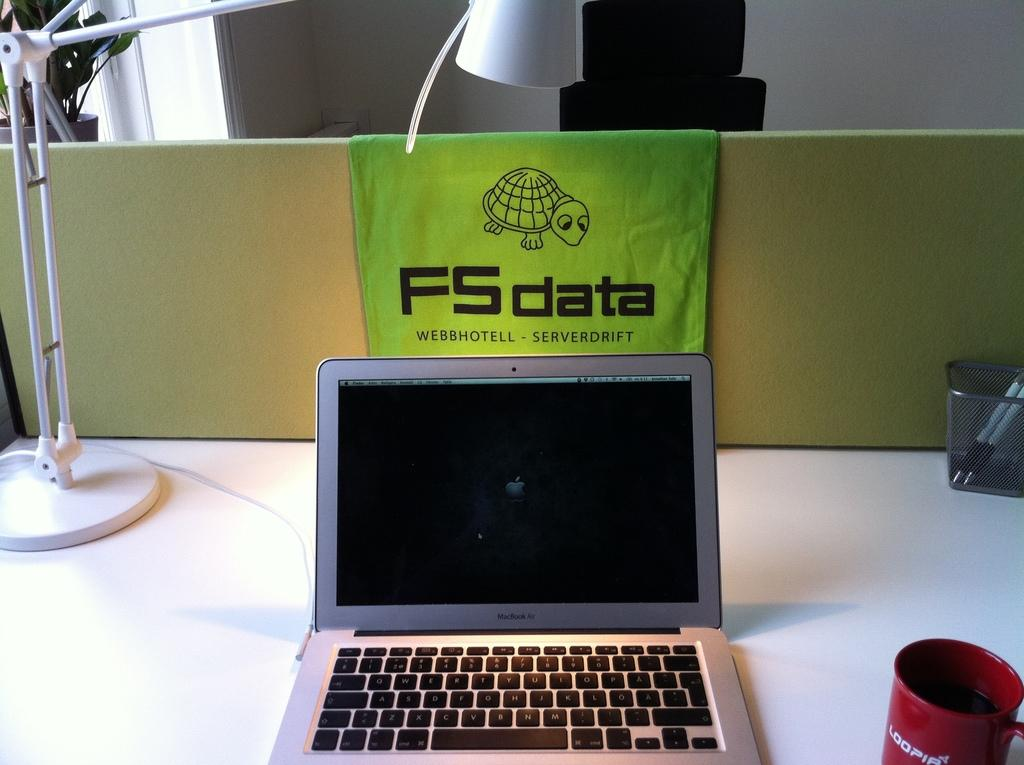<image>
Relay a brief, clear account of the picture shown. An open Macbook Air in front of a small FS Data banner. 